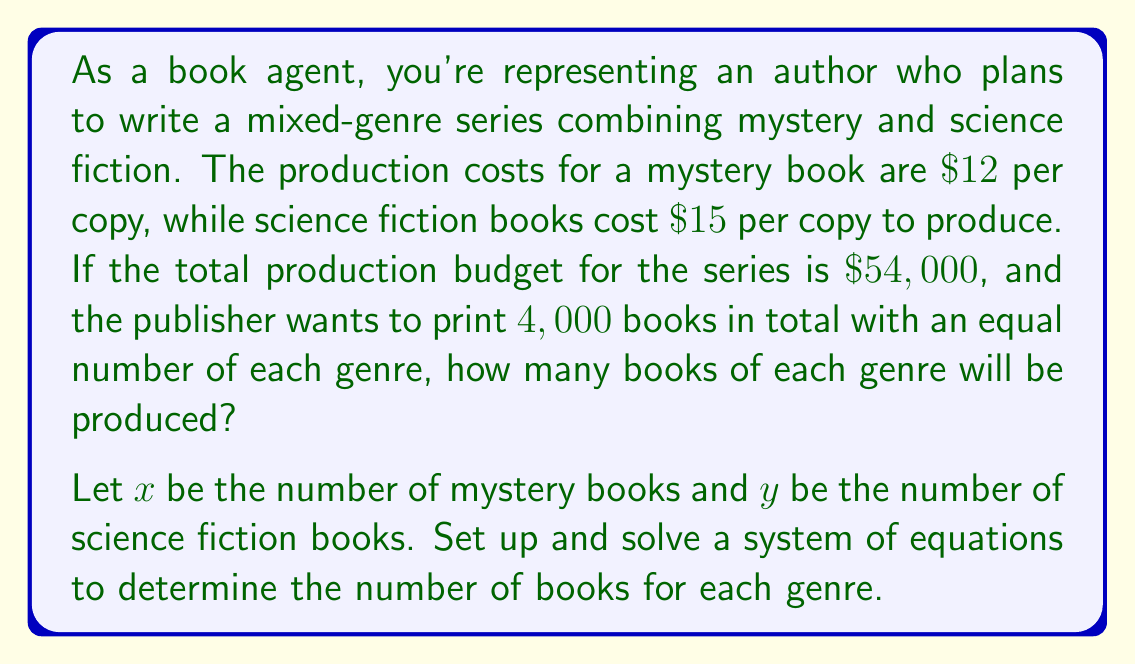Help me with this question. To solve this problem, we need to set up a system of two equations based on the given information:

1. The total number of books is 4,000, and there should be an equal number of each genre:
   $$x + y = 4000$$
   $$x = y$$

2. The total production cost should equal $54,000:
   $$12x + 15y = 54000$$

Now, let's solve this system of equations:

Step 1: Since $x = y$, we can substitute $y$ for $x$ in the cost equation:
$$12x + 15x = 54000$$
$$27x = 54000$$

Step 2: Solve for $x$:
$$x = \frac{54000}{27} = 2000$$

Step 3: Since $x = y$, we know that $y$ is also 2000.

Step 4: Verify the solution:
- Total number of books: $2000 + 2000 = 4000$ ✓
- Total cost: $12(2000) + 15(2000) = 24000 + 30000 = 54000$ ✓

Therefore, the publisher will produce 2000 mystery books and 2000 science fiction books.
Answer: 2000 mystery books and 2000 science fiction books 